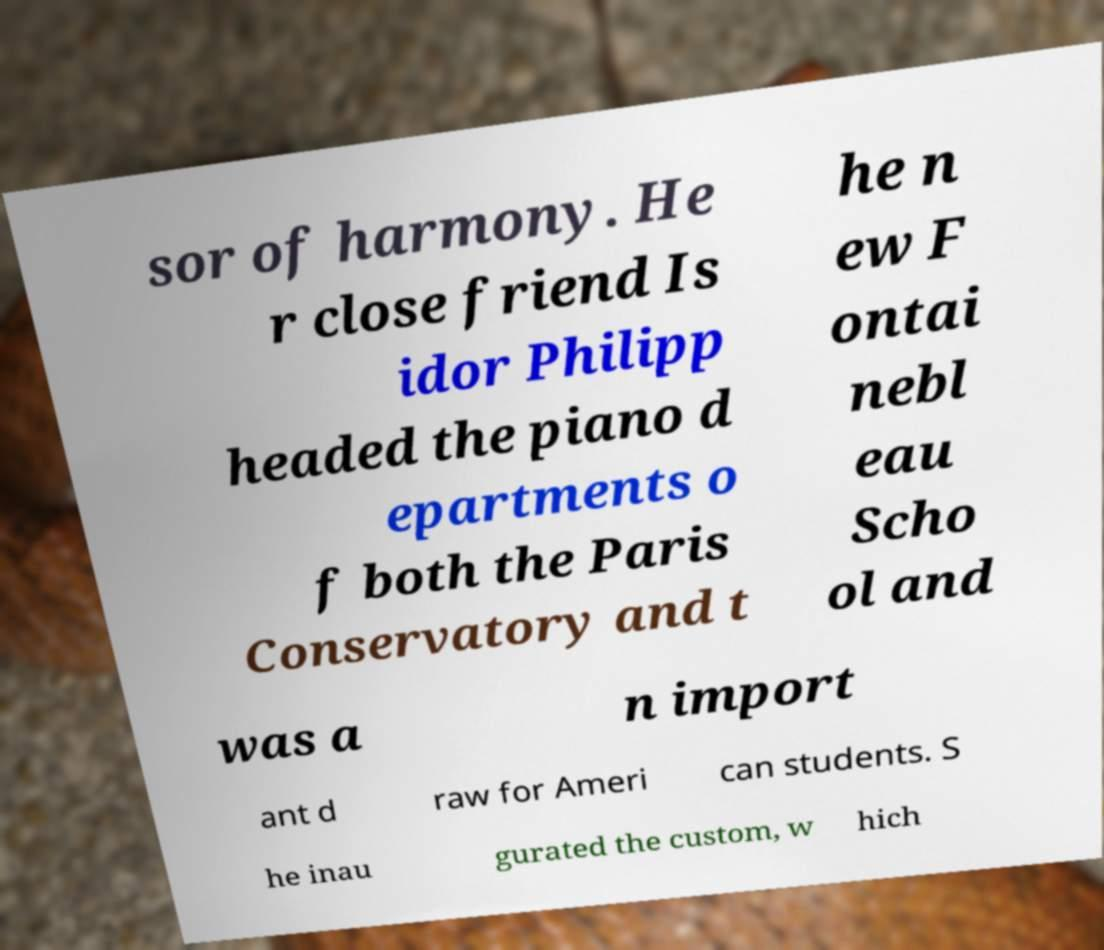Could you extract and type out the text from this image? sor of harmony. He r close friend Is idor Philipp headed the piano d epartments o f both the Paris Conservatory and t he n ew F ontai nebl eau Scho ol and was a n import ant d raw for Ameri can students. S he inau gurated the custom, w hich 